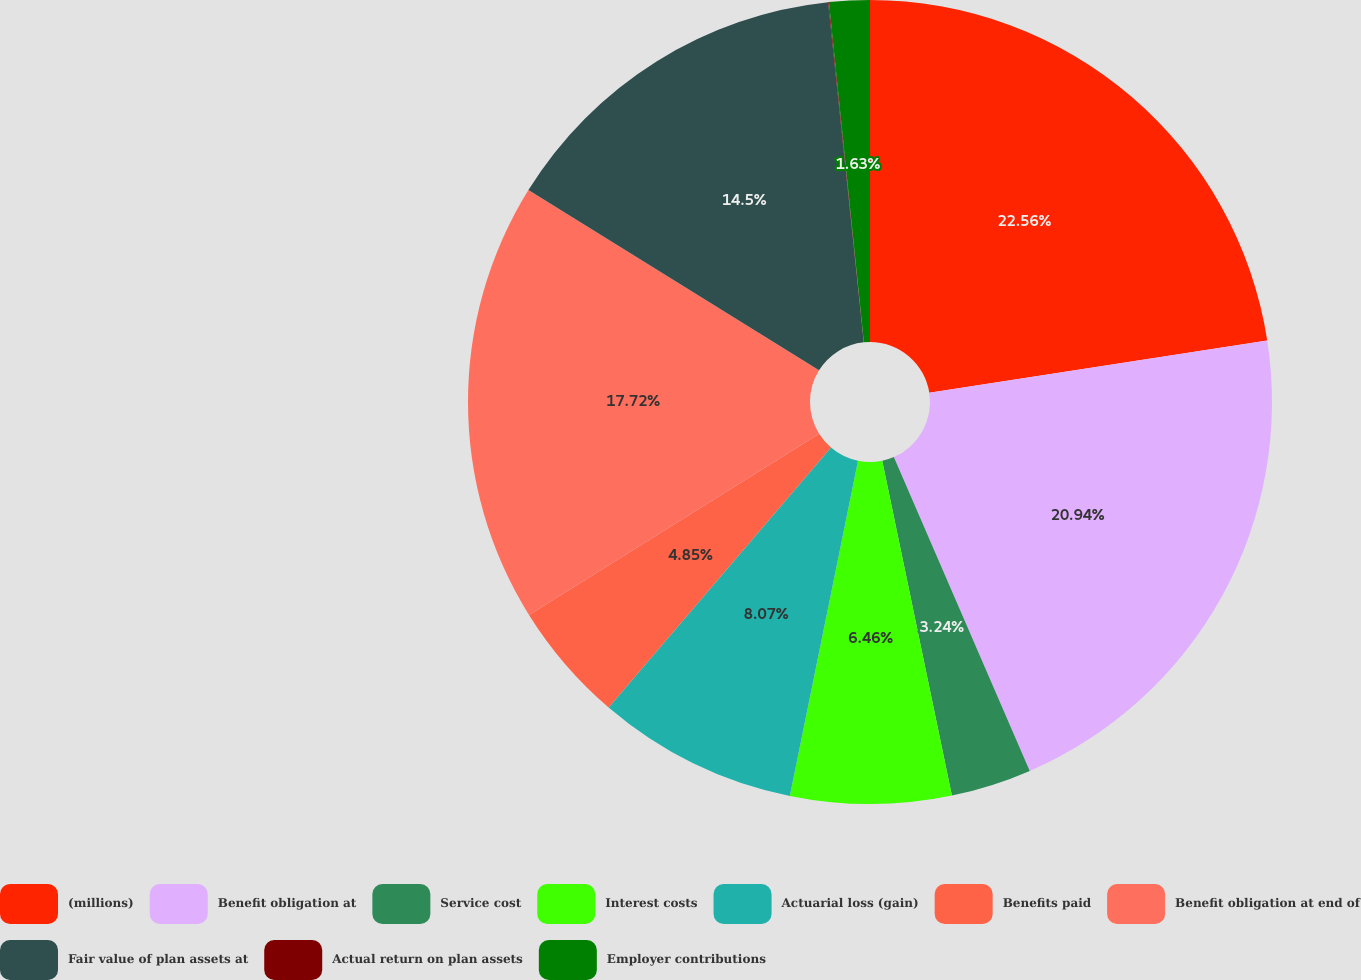Convert chart. <chart><loc_0><loc_0><loc_500><loc_500><pie_chart><fcel>(millions)<fcel>Benefit obligation at<fcel>Service cost<fcel>Interest costs<fcel>Actuarial loss (gain)<fcel>Benefits paid<fcel>Benefit obligation at end of<fcel>Fair value of plan assets at<fcel>Actual return on plan assets<fcel>Employer contributions<nl><fcel>22.55%<fcel>20.94%<fcel>3.24%<fcel>6.46%<fcel>8.07%<fcel>4.85%<fcel>17.72%<fcel>14.5%<fcel>0.03%<fcel>1.63%<nl></chart> 